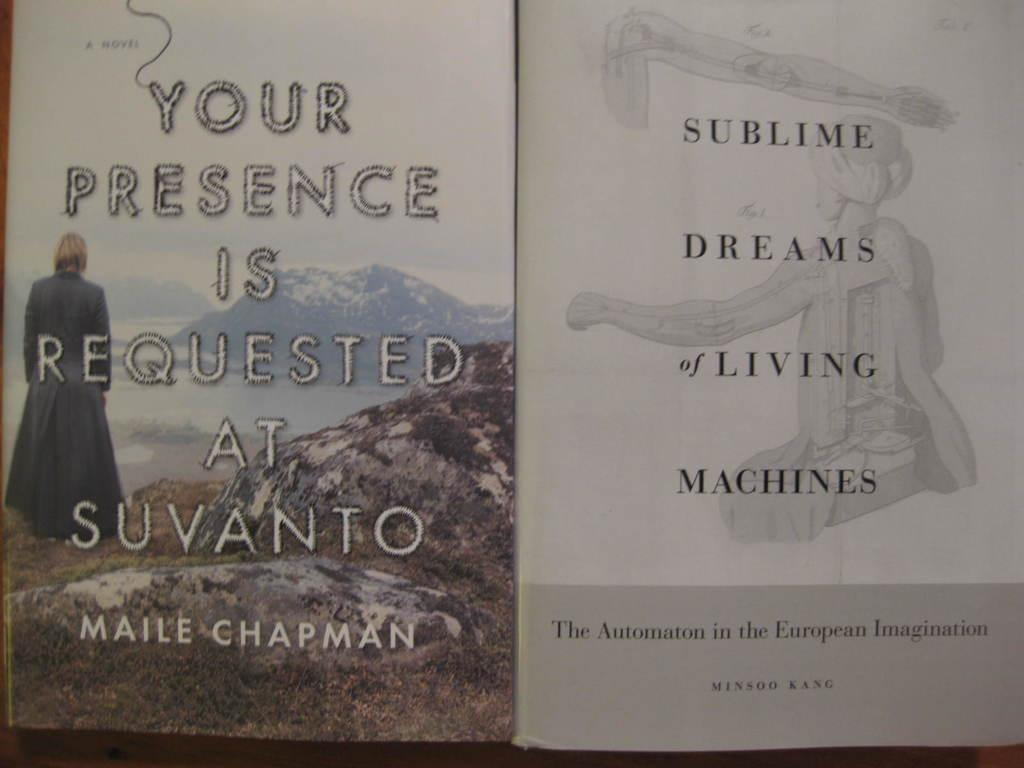<image>
Provide a brief description of the given image. The book "Your Presence is Requested at Suvanto" next to the book "Sublime Dreams of Living Machines". 